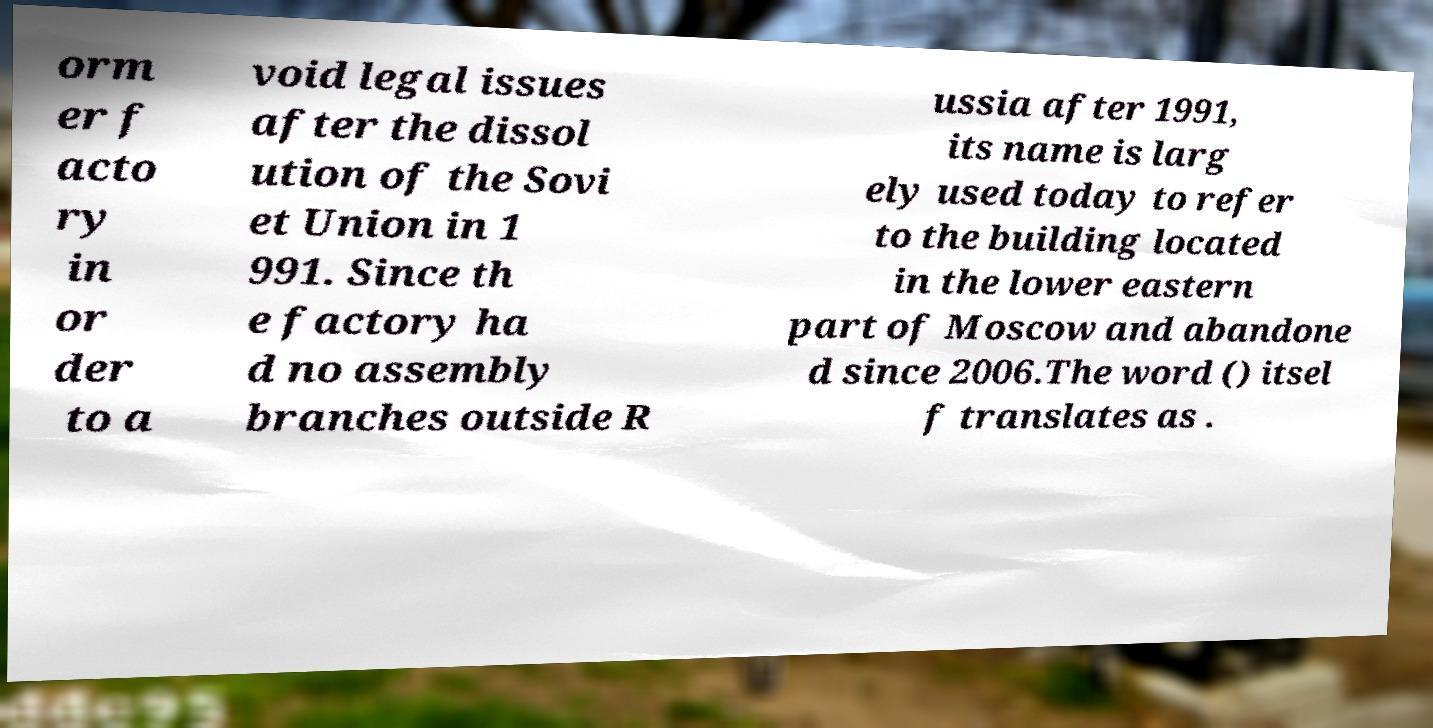Please identify and transcribe the text found in this image. orm er f acto ry in or der to a void legal issues after the dissol ution of the Sovi et Union in 1 991. Since th e factory ha d no assembly branches outside R ussia after 1991, its name is larg ely used today to refer to the building located in the lower eastern part of Moscow and abandone d since 2006.The word () itsel f translates as . 